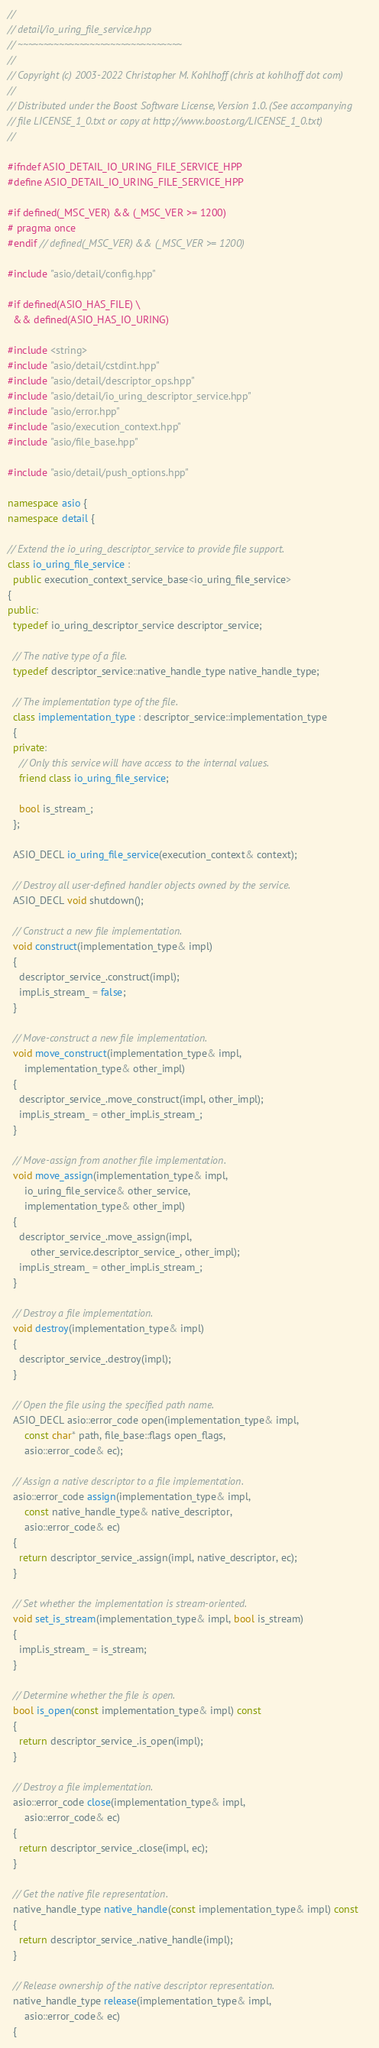Convert code to text. <code><loc_0><loc_0><loc_500><loc_500><_C++_>//
// detail/io_uring_file_service.hpp
// ~~~~~~~~~~~~~~~~~~~~~~~~~~~~~~~~
//
// Copyright (c) 2003-2022 Christopher M. Kohlhoff (chris at kohlhoff dot com)
//
// Distributed under the Boost Software License, Version 1.0. (See accompanying
// file LICENSE_1_0.txt or copy at http://www.boost.org/LICENSE_1_0.txt)
//

#ifndef ASIO_DETAIL_IO_URING_FILE_SERVICE_HPP
#define ASIO_DETAIL_IO_URING_FILE_SERVICE_HPP

#if defined(_MSC_VER) && (_MSC_VER >= 1200)
# pragma once
#endif // defined(_MSC_VER) && (_MSC_VER >= 1200)

#include "asio/detail/config.hpp"

#if defined(ASIO_HAS_FILE) \
  && defined(ASIO_HAS_IO_URING)

#include <string>
#include "asio/detail/cstdint.hpp"
#include "asio/detail/descriptor_ops.hpp"
#include "asio/detail/io_uring_descriptor_service.hpp"
#include "asio/error.hpp"
#include "asio/execution_context.hpp"
#include "asio/file_base.hpp"

#include "asio/detail/push_options.hpp"

namespace asio {
namespace detail {

// Extend the io_uring_descriptor_service to provide file support.
class io_uring_file_service :
  public execution_context_service_base<io_uring_file_service>
{
public:
  typedef io_uring_descriptor_service descriptor_service;

  // The native type of a file.
  typedef descriptor_service::native_handle_type native_handle_type;

  // The implementation type of the file.
  class implementation_type : descriptor_service::implementation_type
  {
  private:
    // Only this service will have access to the internal values.
    friend class io_uring_file_service;

    bool is_stream_;
  };

  ASIO_DECL io_uring_file_service(execution_context& context);

  // Destroy all user-defined handler objects owned by the service.
  ASIO_DECL void shutdown();

  // Construct a new file implementation.
  void construct(implementation_type& impl)
  {
    descriptor_service_.construct(impl);
    impl.is_stream_ = false;
  }

  // Move-construct a new file implementation.
  void move_construct(implementation_type& impl,
      implementation_type& other_impl)
  {
    descriptor_service_.move_construct(impl, other_impl);
    impl.is_stream_ = other_impl.is_stream_;
  }

  // Move-assign from another file implementation.
  void move_assign(implementation_type& impl,
      io_uring_file_service& other_service,
      implementation_type& other_impl)
  {
    descriptor_service_.move_assign(impl,
        other_service.descriptor_service_, other_impl);
    impl.is_stream_ = other_impl.is_stream_;
  }

  // Destroy a file implementation.
  void destroy(implementation_type& impl)
  {
    descriptor_service_.destroy(impl);
  }

  // Open the file using the specified path name.
  ASIO_DECL asio::error_code open(implementation_type& impl,
      const char* path, file_base::flags open_flags,
      asio::error_code& ec);

  // Assign a native descriptor to a file implementation.
  asio::error_code assign(implementation_type& impl,
      const native_handle_type& native_descriptor,
      asio::error_code& ec)
  {
    return descriptor_service_.assign(impl, native_descriptor, ec);
  }

  // Set whether the implementation is stream-oriented.
  void set_is_stream(implementation_type& impl, bool is_stream)
  {
    impl.is_stream_ = is_stream;
  }

  // Determine whether the file is open.
  bool is_open(const implementation_type& impl) const
  {
    return descriptor_service_.is_open(impl);
  }

  // Destroy a file implementation.
  asio::error_code close(implementation_type& impl,
      asio::error_code& ec)
  {
    return descriptor_service_.close(impl, ec);
  }

  // Get the native file representation.
  native_handle_type native_handle(const implementation_type& impl) const
  {
    return descriptor_service_.native_handle(impl);
  }

  // Release ownership of the native descriptor representation.
  native_handle_type release(implementation_type& impl,
      asio::error_code& ec)
  {</code> 